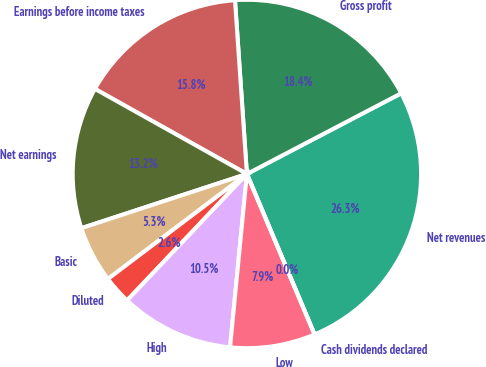Convert chart. <chart><loc_0><loc_0><loc_500><loc_500><pie_chart><fcel>Net revenues<fcel>Gross profit<fcel>Earnings before income taxes<fcel>Net earnings<fcel>Basic<fcel>Diluted<fcel>High<fcel>Low<fcel>Cash dividends declared<nl><fcel>26.32%<fcel>18.42%<fcel>15.79%<fcel>13.16%<fcel>5.26%<fcel>2.63%<fcel>10.53%<fcel>7.89%<fcel>0.0%<nl></chart> 